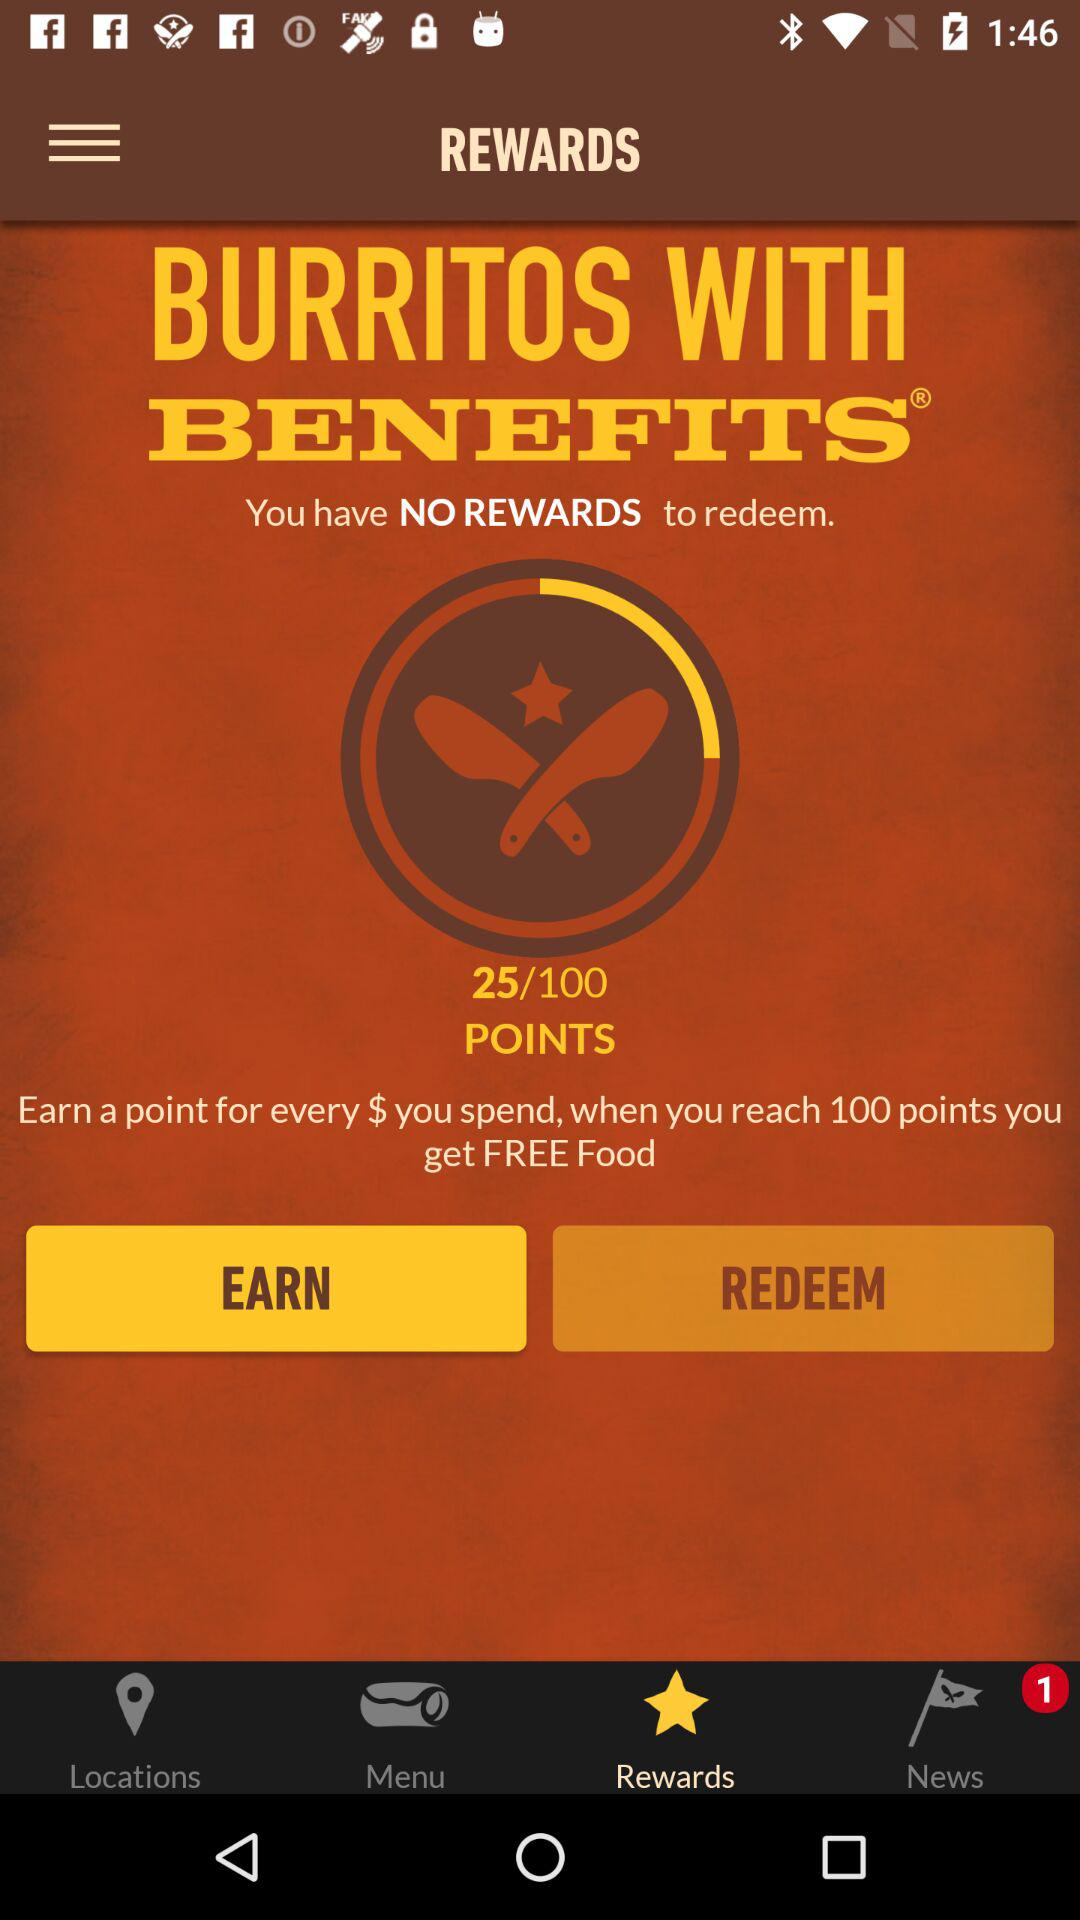How many points did I earn? You have earned 25 points. 